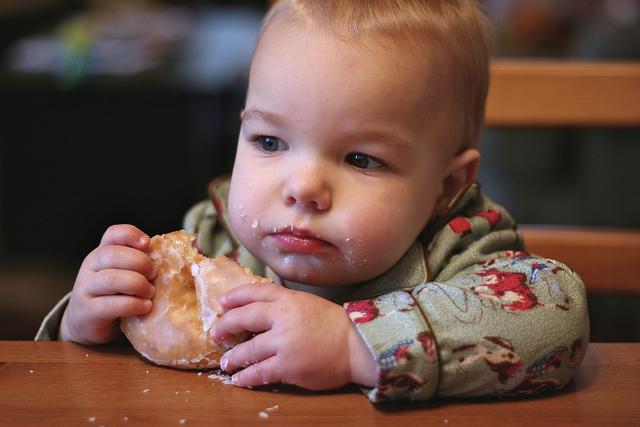What is the baby eating?
Keep it brief. Donut. What is the table made of?
Concise answer only. Wood. How old is the child?
Short answer required. 1. What food is the baby eating?
Answer briefly. Donut. Is this a boy or a girl?
Concise answer only. Boy. 